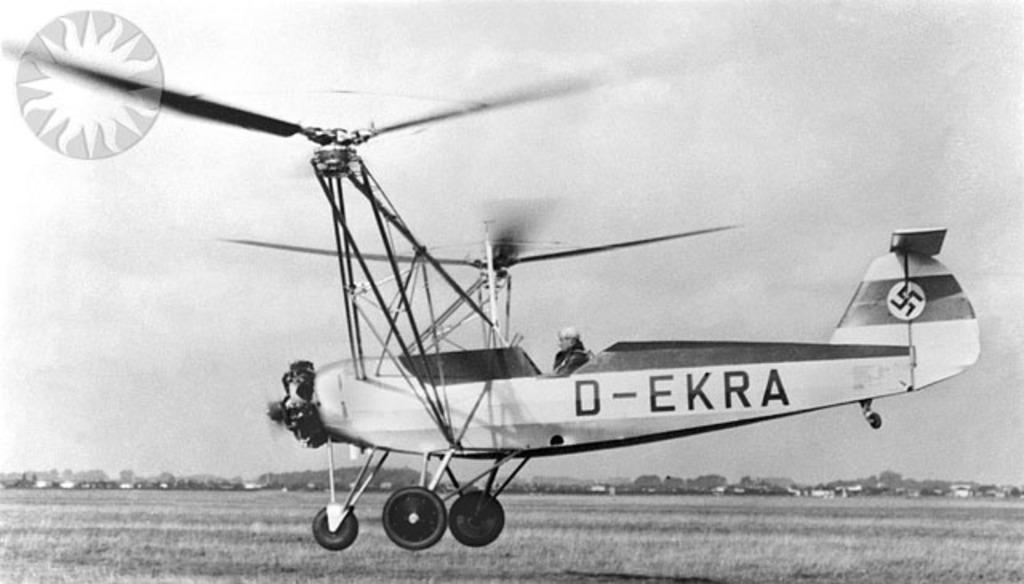Can you describe this image briefly? In the foreground of this black and white image, there is an airplane in the air above the ground. In the background, there is the sky. At the top left, there is a watermark. 